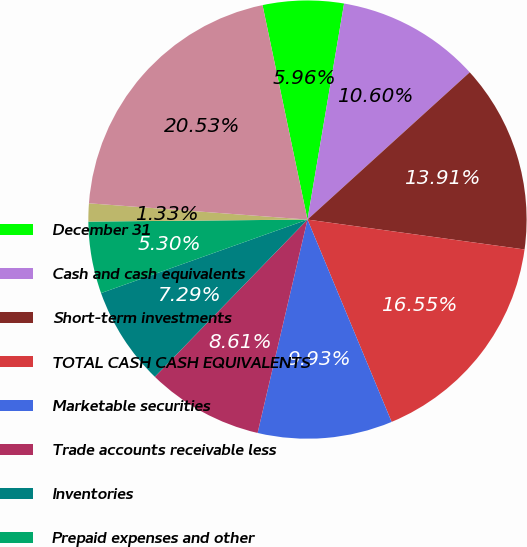Convert chart to OTSL. <chart><loc_0><loc_0><loc_500><loc_500><pie_chart><fcel>December 31<fcel>Cash and cash equivalents<fcel>Short-term investments<fcel>TOTAL CASH CASH EQUIVALENTS<fcel>Marketable securities<fcel>Trade accounts receivable less<fcel>Inventories<fcel>Prepaid expenses and other<fcel>Assets held for sale<fcel>TOTAL CURRENT ASSETS<nl><fcel>5.96%<fcel>10.6%<fcel>13.91%<fcel>16.55%<fcel>9.93%<fcel>8.61%<fcel>7.29%<fcel>5.3%<fcel>1.33%<fcel>20.53%<nl></chart> 